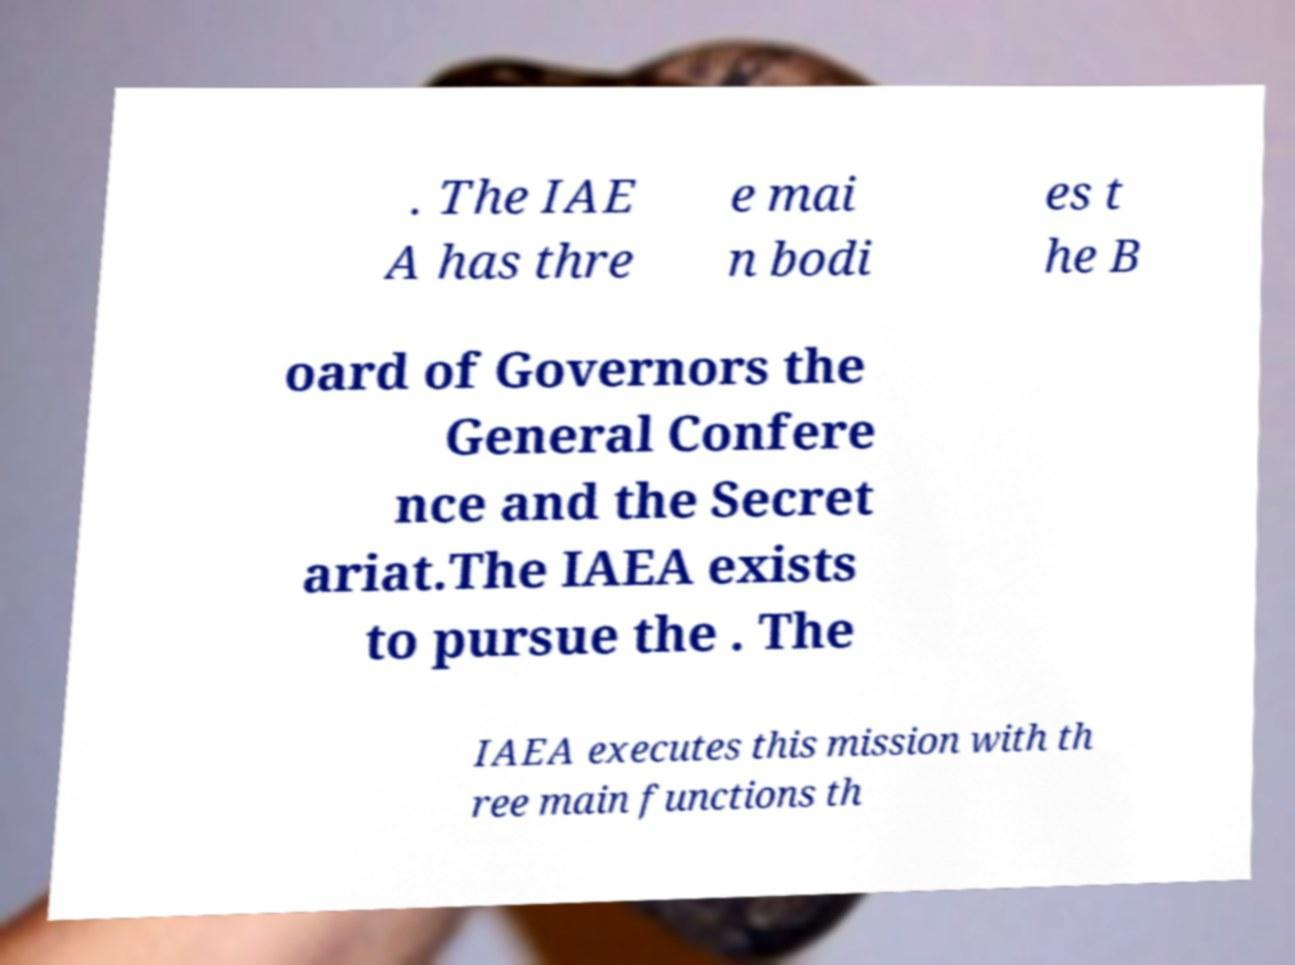Could you extract and type out the text from this image? . The IAE A has thre e mai n bodi es t he B oard of Governors the General Confere nce and the Secret ariat.The IAEA exists to pursue the . The IAEA executes this mission with th ree main functions th 